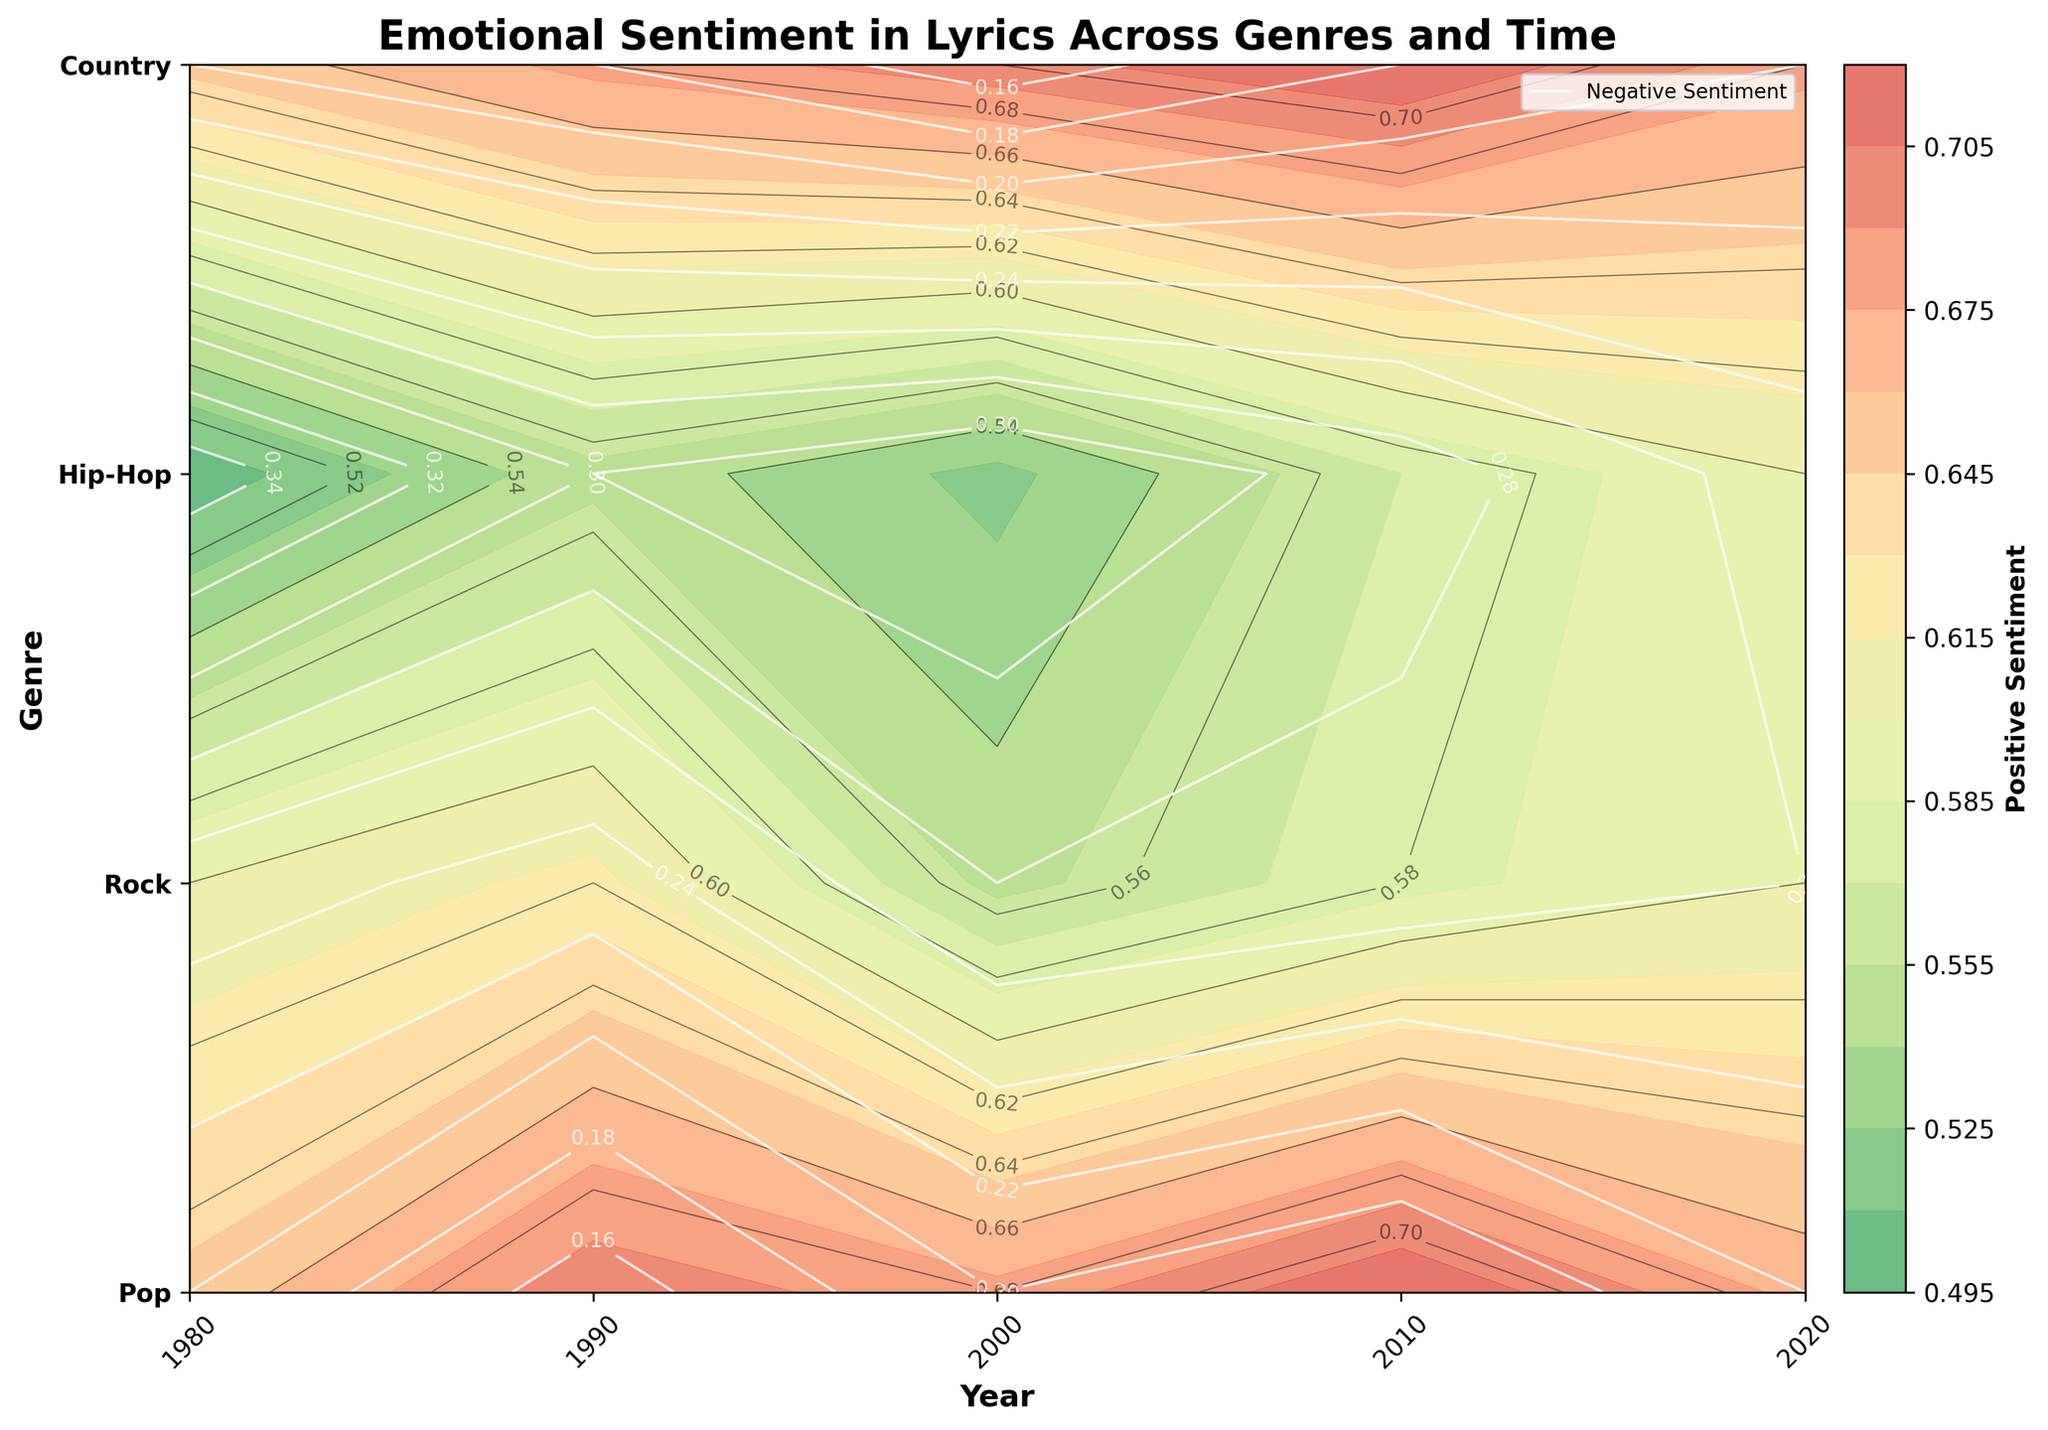What is the title of the figure? The title of a figure is usually found at the top and it clearly indicates the main topic or data being depicted. In this case, the title is "Emotional Sentiment in Lyrics Across Genres and Time".
Answer: Emotional Sentiment in Lyrics Across Genres and Time Which genre shows a decrease in positive sentiment from 2000 to 2010? By observing the positive sentiment contours, we note the values associated with each year for each genre. Rock shows a decrease from 0.55 in 2000 to 0.58 in 2010.
Answer: Rock How does the negative sentiment for Hip-Hop in 1980 compare to 2020? We compare the contour lines for negative sentiment in Hip-Hop for the years 1980 and 2020. In 1980, the negative sentiment is at 0.35 and it decreases to 0.25 by 2020.
Answer: It decreased Which year has the highest positive sentiment across all genres? By comparing the contour levels of positive sentiment across all years and genres, we observe that the highest positive sentiment is around 0.72 in 2010 for both Pop and Country.
Answer: 2010 Among the genres, which one maintained a stable positive sentiment from 1980 to 2020? By reviewing the positive sentiment contours for each genre over the years, Pop and Country show relatively stable positive sentiments over time. However, Country shows a bit more stability with consistently high values.
Answer: Country What is the general trend in negative sentiment for Rock music from 1980 to 2020? By examining the contours for negative sentiment in Rock, we observe that it starts at 0.25 in 1980 and fluctuates minimally to 0.26 in 2020. It shows a small upward trend.
Answer: Slight increase Which genre exhibits the highest variance in positive sentiment over the years? By observing how much the positive sentiment contour fluctuates for each genre, Hip-Hop seems to have notable changes from 0.5 in 1980 to 0.6 in 2020.
Answer: Hip-Hop Which year shows the highest negative sentiment overall? By checking the contour levels for negative sentiment across all the years, 1980 shows a peak in negative sentiment, particularly for Hip-Hop (0.35).
Answer: 1980 How does Country music's positive sentiment in 1990 differ from its negative sentiment in 1990? Reviewing the contour plots, we see that Country music in 1990 has a positive sentiment of 0.68 and a negative sentiment of 0.18.
Answer: Positive sentiment is higher than negative sentiment Are there any genres with similar negative sentiment values in 2020? By looking at the contours for negative sentiment in 2020, both Rock and Hip-Hop exhibit similar values of approximately 0.26.
Answer: Rock and Hip-Hop 